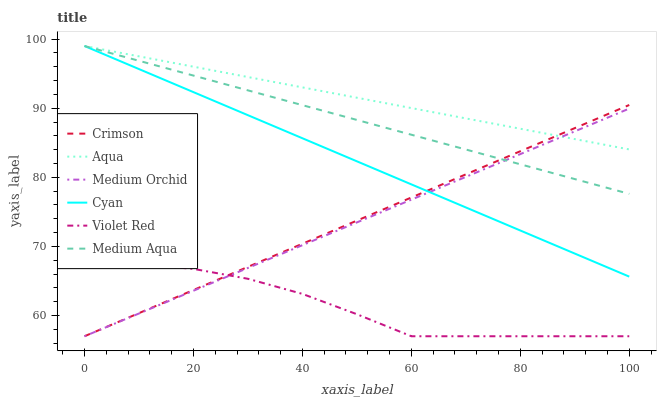Does Violet Red have the minimum area under the curve?
Answer yes or no. Yes. Does Aqua have the maximum area under the curve?
Answer yes or no. Yes. Does Medium Orchid have the minimum area under the curve?
Answer yes or no. No. Does Medium Orchid have the maximum area under the curve?
Answer yes or no. No. Is Crimson the smoothest?
Answer yes or no. Yes. Is Violet Red the roughest?
Answer yes or no. Yes. Is Medium Orchid the smoothest?
Answer yes or no. No. Is Medium Orchid the roughest?
Answer yes or no. No. Does Violet Red have the lowest value?
Answer yes or no. Yes. Does Aqua have the lowest value?
Answer yes or no. No. Does Cyan have the highest value?
Answer yes or no. Yes. Does Medium Orchid have the highest value?
Answer yes or no. No. Is Violet Red less than Medium Aqua?
Answer yes or no. Yes. Is Cyan greater than Violet Red?
Answer yes or no. Yes. Does Aqua intersect Medium Orchid?
Answer yes or no. Yes. Is Aqua less than Medium Orchid?
Answer yes or no. No. Is Aqua greater than Medium Orchid?
Answer yes or no. No. Does Violet Red intersect Medium Aqua?
Answer yes or no. No. 